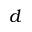<formula> <loc_0><loc_0><loc_500><loc_500>d</formula> 